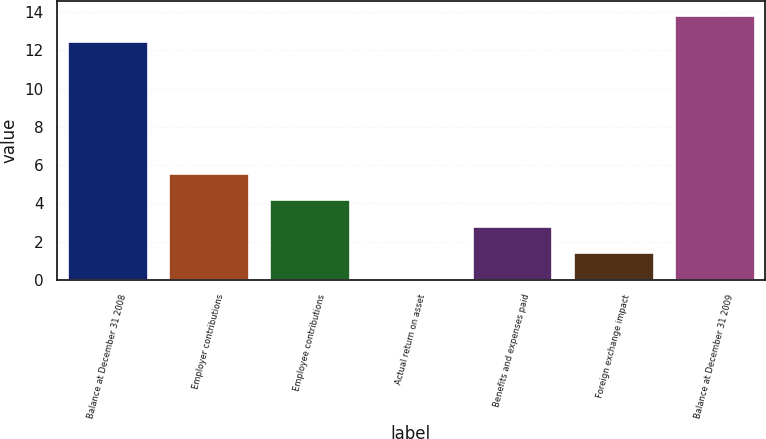Convert chart. <chart><loc_0><loc_0><loc_500><loc_500><bar_chart><fcel>Balance at December 31 2008<fcel>Employer contributions<fcel>Employee contributions<fcel>Actual return on asset<fcel>Benefits and expenses paid<fcel>Foreign exchange impact<fcel>Balance at December 31 2009<nl><fcel>12.5<fcel>5.58<fcel>4.21<fcel>0.1<fcel>2.84<fcel>1.47<fcel>13.87<nl></chart> 